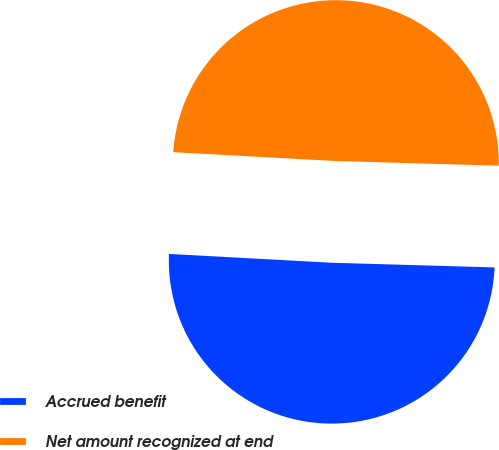<chart> <loc_0><loc_0><loc_500><loc_500><pie_chart><fcel>Accrued benefit<fcel>Net amount recognized at end<nl><fcel>50.41%<fcel>49.59%<nl></chart> 